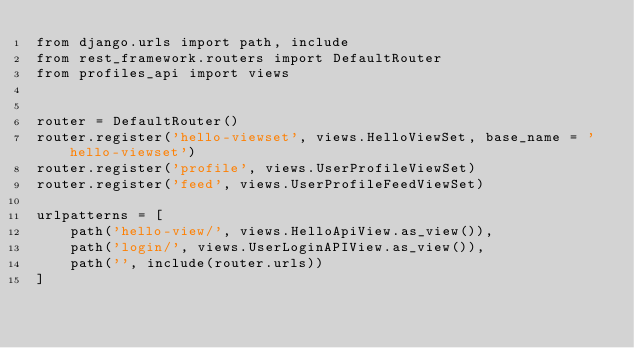<code> <loc_0><loc_0><loc_500><loc_500><_Python_>from django.urls import path, include
from rest_framework.routers import DefaultRouter
from profiles_api import views


router = DefaultRouter()
router.register('hello-viewset', views.HelloViewSet, base_name = 'hello-viewset')
router.register('profile', views.UserProfileViewSet)
router.register('feed', views.UserProfileFeedViewSet)

urlpatterns = [
    path('hello-view/', views.HelloApiView.as_view()),
    path('login/', views.UserLoginAPIView.as_view()),
    path('', include(router.urls))
]
</code> 